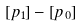<formula> <loc_0><loc_0><loc_500><loc_500>[ p _ { 1 } ] - [ p _ { 0 } ]</formula> 